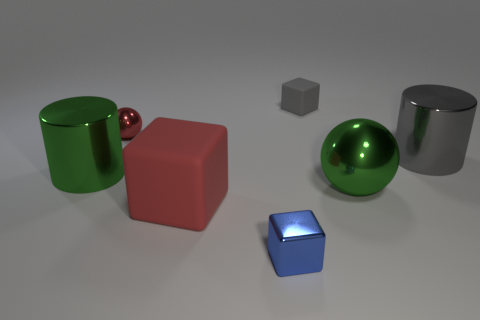Add 1 big yellow things. How many objects exist? 8 Subtract all cylinders. How many objects are left? 5 Subtract 0 brown cylinders. How many objects are left? 7 Subtract all small metal things. Subtract all big purple metal things. How many objects are left? 5 Add 2 big rubber blocks. How many big rubber blocks are left? 3 Add 6 green balls. How many green balls exist? 7 